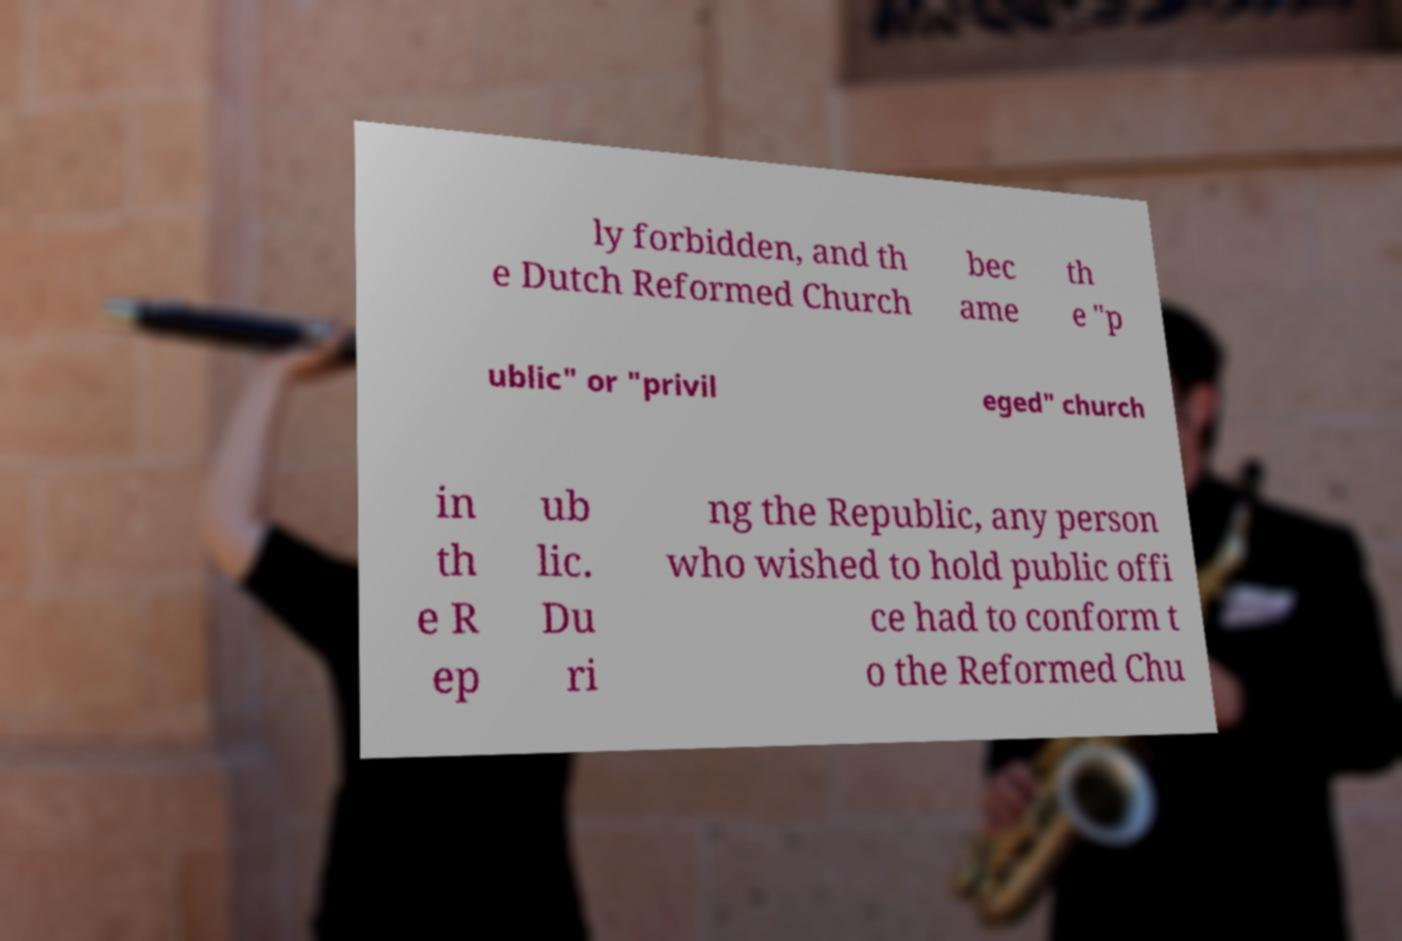Could you assist in decoding the text presented in this image and type it out clearly? ly forbidden, and th e Dutch Reformed Church bec ame th e "p ublic" or "privil eged" church in th e R ep ub lic. Du ri ng the Republic, any person who wished to hold public offi ce had to conform t o the Reformed Chu 